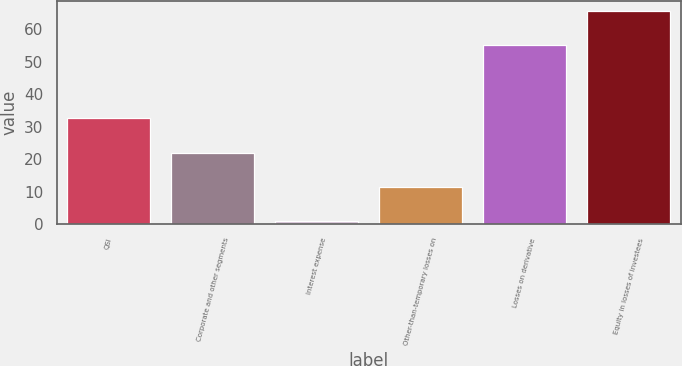Convert chart. <chart><loc_0><loc_0><loc_500><loc_500><bar_chart><fcel>QSI<fcel>Corporate and other segments<fcel>Interest expense<fcel>Other-than-temporary losses on<fcel>Losses on derivative<fcel>Equity in losses of investees<nl><fcel>32.5<fcel>22<fcel>1<fcel>11.5<fcel>55<fcel>65.5<nl></chart> 